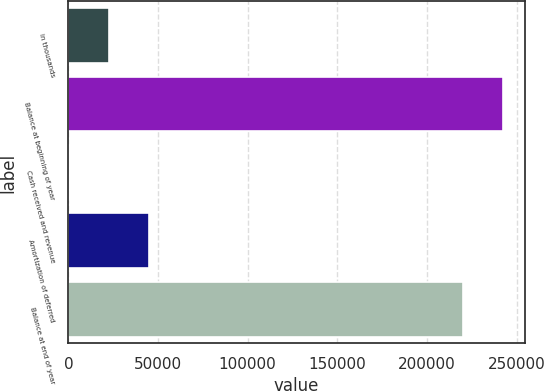Convert chart to OTSL. <chart><loc_0><loc_0><loc_500><loc_500><bar_chart><fcel>in thousands<fcel>Balance at beginning of year<fcel>Cash received and revenue<fcel>Amortization of deferred<fcel>Balance at end of year<nl><fcel>22642.6<fcel>242424<fcel>187<fcel>45098.2<fcel>219968<nl></chart> 